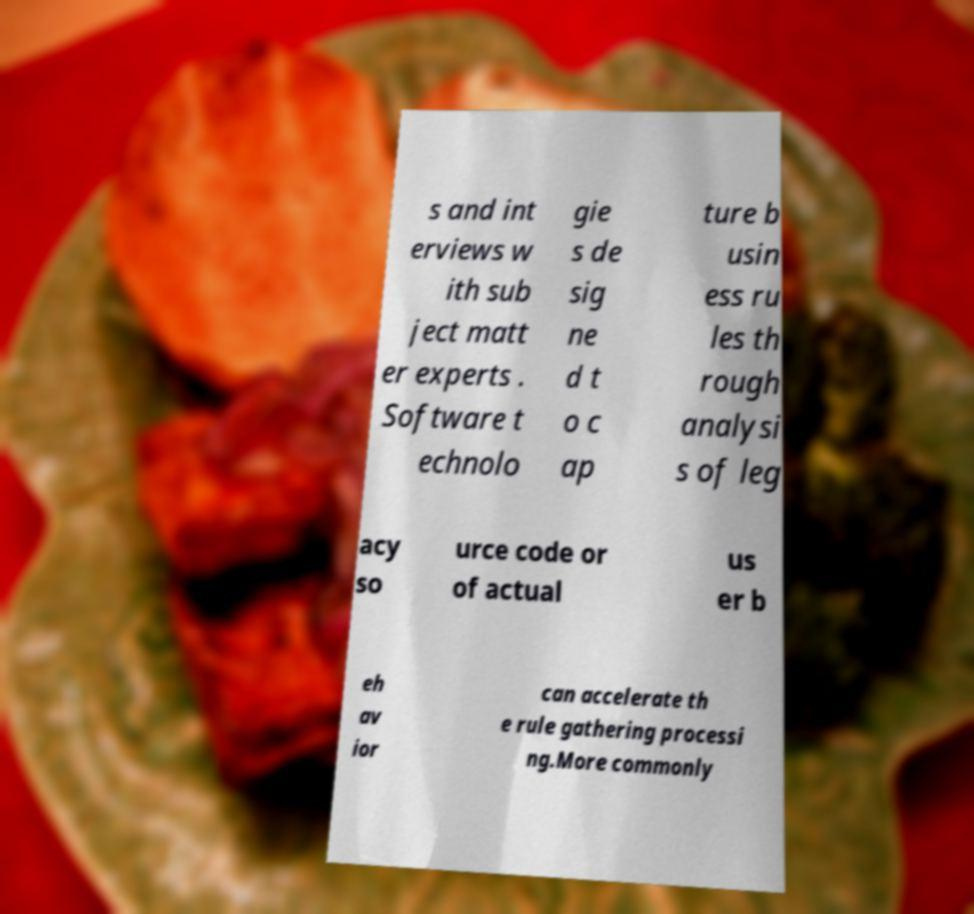There's text embedded in this image that I need extracted. Can you transcribe it verbatim? s and int erviews w ith sub ject matt er experts . Software t echnolo gie s de sig ne d t o c ap ture b usin ess ru les th rough analysi s of leg acy so urce code or of actual us er b eh av ior can accelerate th e rule gathering processi ng.More commonly 